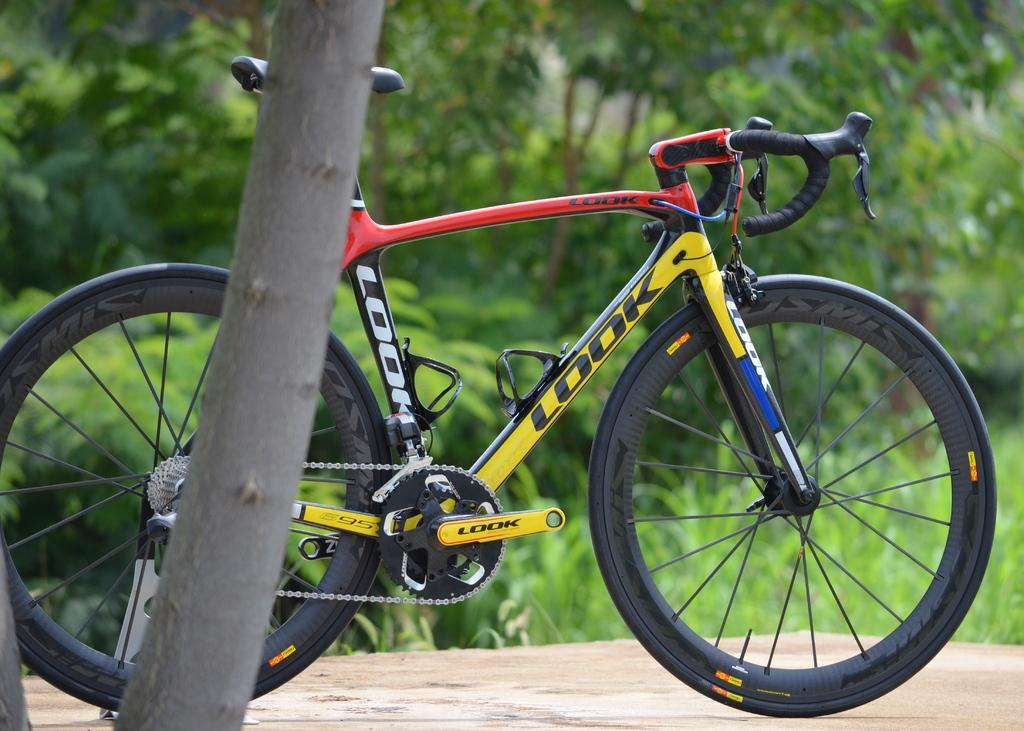What is the main object in the image? There is a bicycle in the image. Where is the bicycle located? The bicycle is parked near a tree. What can be seen in the background of the image? There are plants, trees, and grass in the background of the image. What type of bears can be seen playing volleyball in the image? There are no bears or volleyball present in the image; it features a bicycle parked near a tree with plants, trees, and grass in the background. What color is the rose on the bicycle in the image? There is no rose present on the bicycle in the image. 